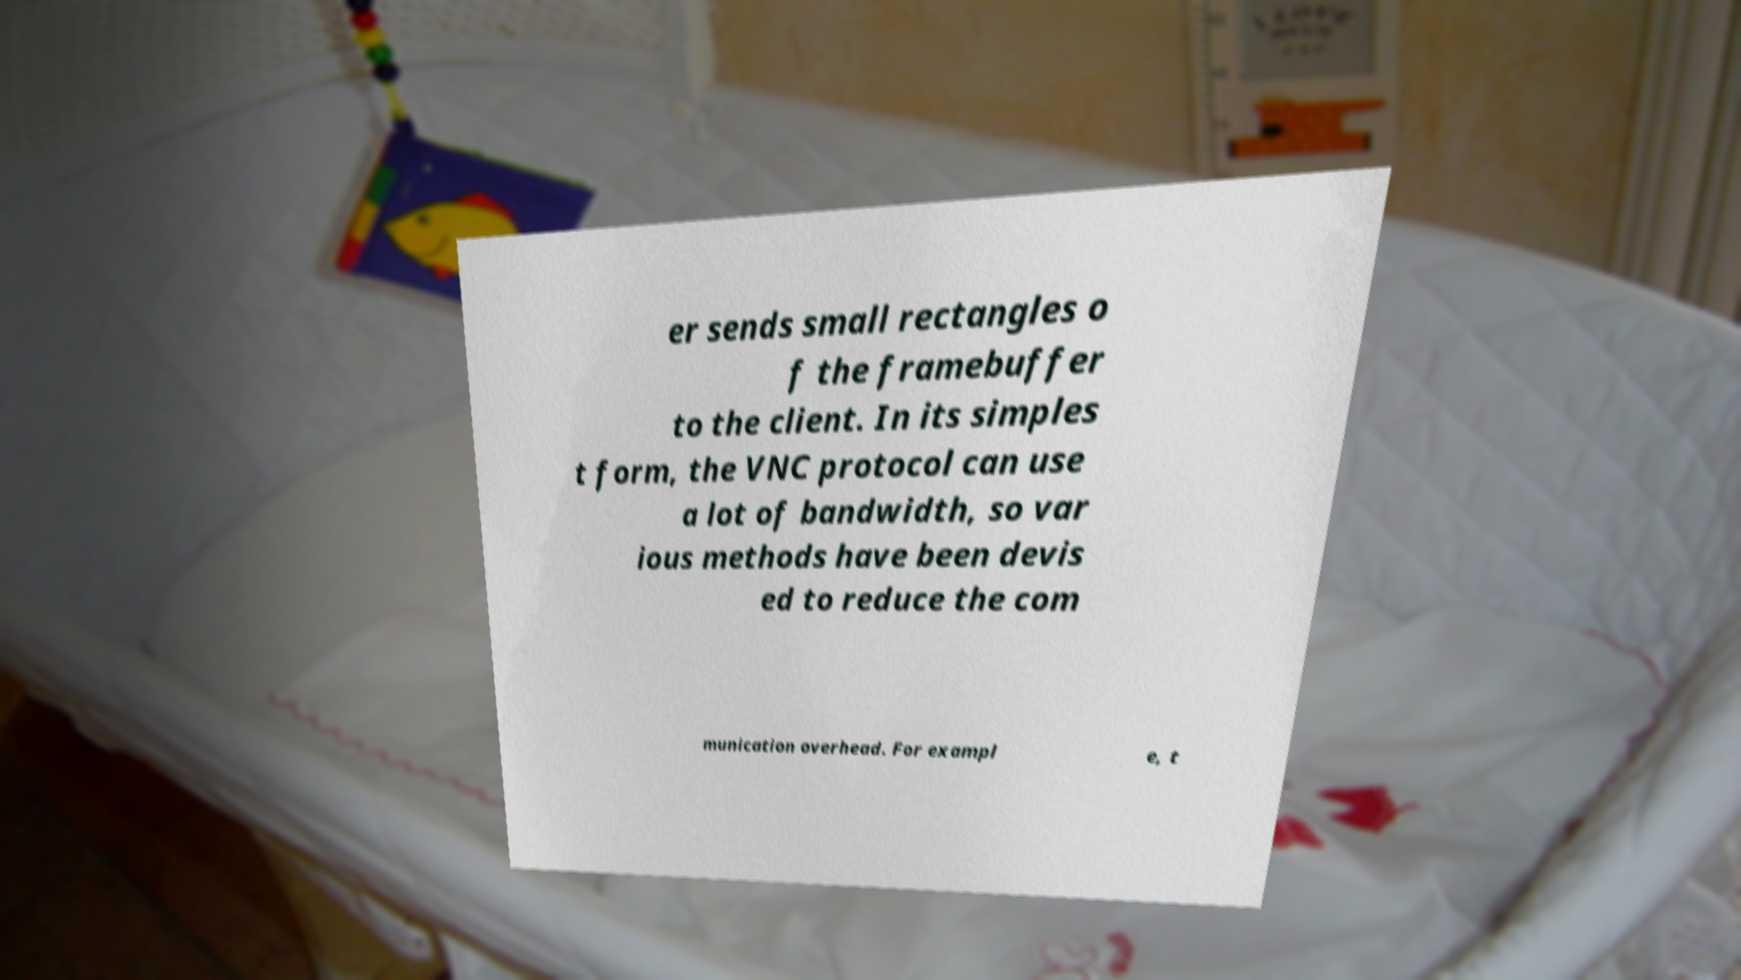Can you read and provide the text displayed in the image?This photo seems to have some interesting text. Can you extract and type it out for me? er sends small rectangles o f the framebuffer to the client. In its simples t form, the VNC protocol can use a lot of bandwidth, so var ious methods have been devis ed to reduce the com munication overhead. For exampl e, t 